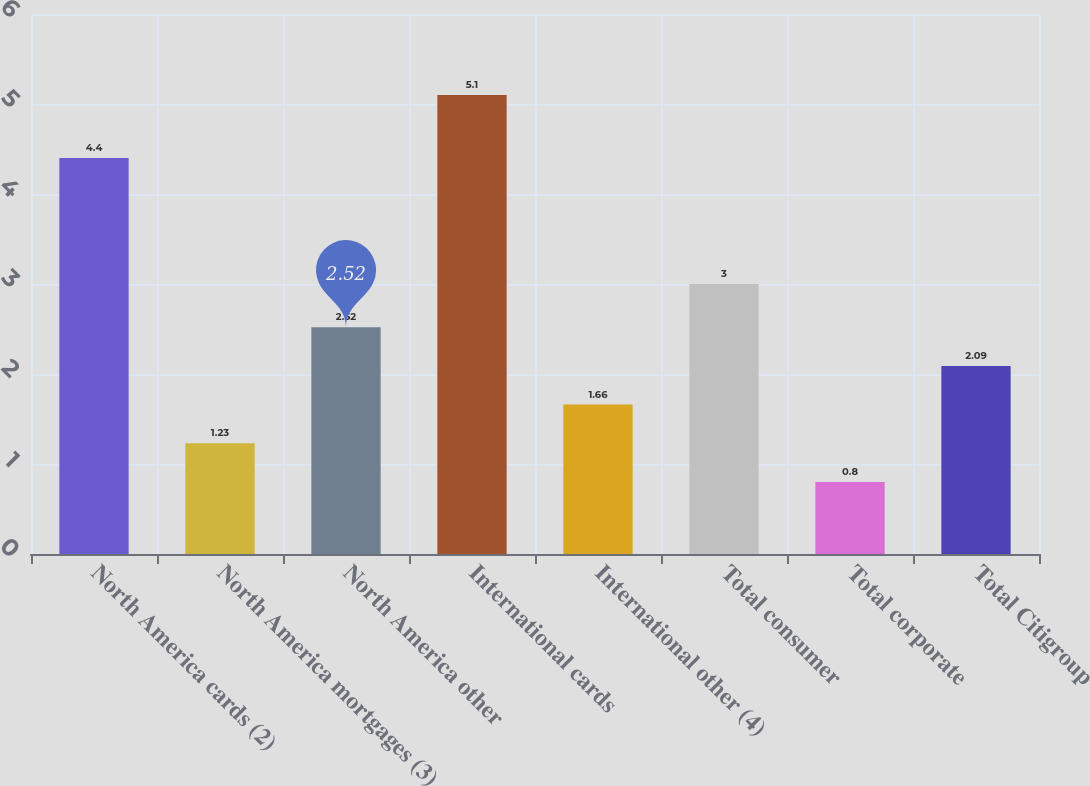Convert chart. <chart><loc_0><loc_0><loc_500><loc_500><bar_chart><fcel>North America cards (2)<fcel>North America mortgages (3)<fcel>North America other<fcel>International cards<fcel>International other (4)<fcel>Total consumer<fcel>Total corporate<fcel>Total Citigroup<nl><fcel>4.4<fcel>1.23<fcel>2.52<fcel>5.1<fcel>1.66<fcel>3<fcel>0.8<fcel>2.09<nl></chart> 